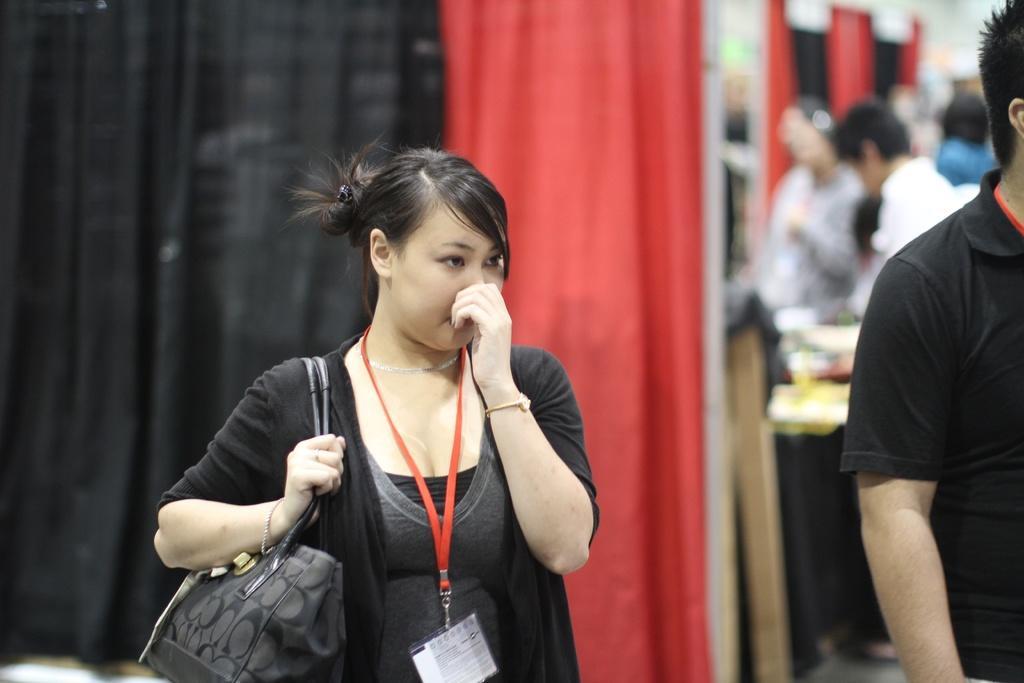How would you summarize this image in a sentence or two? This woman wore black jacket and holding a handbag. This man wore black t-shirt. This is a red and black curtain. For the persons are standing. 